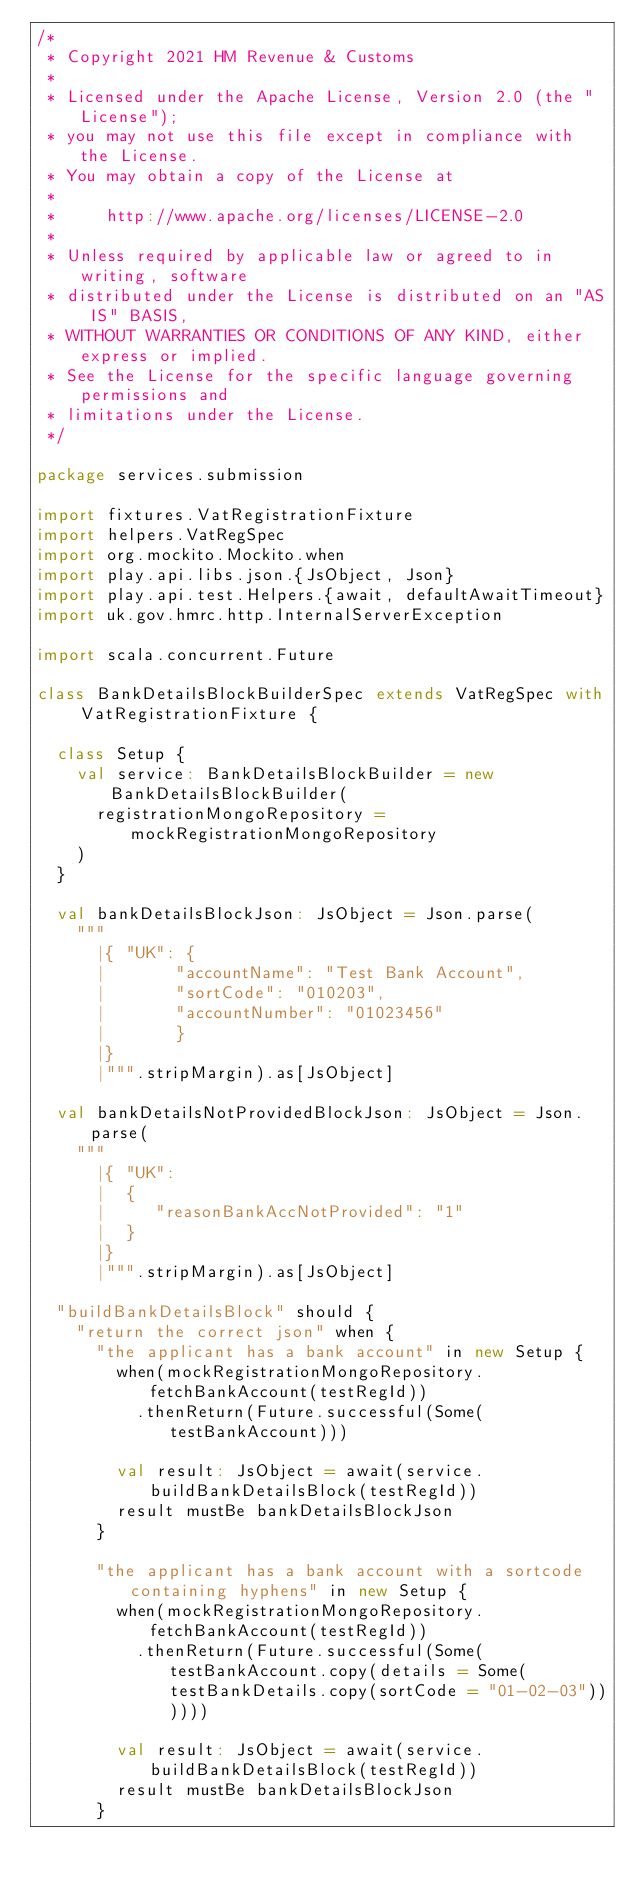<code> <loc_0><loc_0><loc_500><loc_500><_Scala_>/*
 * Copyright 2021 HM Revenue & Customs
 *
 * Licensed under the Apache License, Version 2.0 (the "License");
 * you may not use this file except in compliance with the License.
 * You may obtain a copy of the License at
 *
 *     http://www.apache.org/licenses/LICENSE-2.0
 *
 * Unless required by applicable law or agreed to in writing, software
 * distributed under the License is distributed on an "AS IS" BASIS,
 * WITHOUT WARRANTIES OR CONDITIONS OF ANY KIND, either express or implied.
 * See the License for the specific language governing permissions and
 * limitations under the License.
 */

package services.submission

import fixtures.VatRegistrationFixture
import helpers.VatRegSpec
import org.mockito.Mockito.when
import play.api.libs.json.{JsObject, Json}
import play.api.test.Helpers.{await, defaultAwaitTimeout}
import uk.gov.hmrc.http.InternalServerException

import scala.concurrent.Future

class BankDetailsBlockBuilderSpec extends VatRegSpec with VatRegistrationFixture {

  class Setup {
    val service: BankDetailsBlockBuilder = new BankDetailsBlockBuilder(
      registrationMongoRepository = mockRegistrationMongoRepository
    )
  }

  val bankDetailsBlockJson: JsObject = Json.parse(
    """
      |{ "UK": {
      |       "accountName": "Test Bank Account",
      |       "sortCode": "010203",
      |       "accountNumber": "01023456"
      |       }
      |}
      |""".stripMargin).as[JsObject]

  val bankDetailsNotProvidedBlockJson: JsObject = Json.parse(
    """
      |{ "UK":
      |  {
      |     "reasonBankAccNotProvided": "1"
      |  }
      |}
      |""".stripMargin).as[JsObject]

  "buildBankDetailsBlock" should {
    "return the correct json" when {
      "the applicant has a bank account" in new Setup {
        when(mockRegistrationMongoRepository.fetchBankAccount(testRegId))
          .thenReturn(Future.successful(Some(testBankAccount)))

        val result: JsObject = await(service.buildBankDetailsBlock(testRegId))
        result mustBe bankDetailsBlockJson
      }

      "the applicant has a bank account with a sortcode containing hyphens" in new Setup {
        when(mockRegistrationMongoRepository.fetchBankAccount(testRegId))
          .thenReturn(Future.successful(Some(testBankAccount.copy(details = Some(testBankDetails.copy(sortCode = "01-02-03"))))))

        val result: JsObject = await(service.buildBankDetailsBlock(testRegId))
        result mustBe bankDetailsBlockJson
      }
</code> 